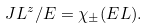<formula> <loc_0><loc_0><loc_500><loc_500>J L ^ { z } / E = \chi _ { \pm } ( E L ) .</formula> 